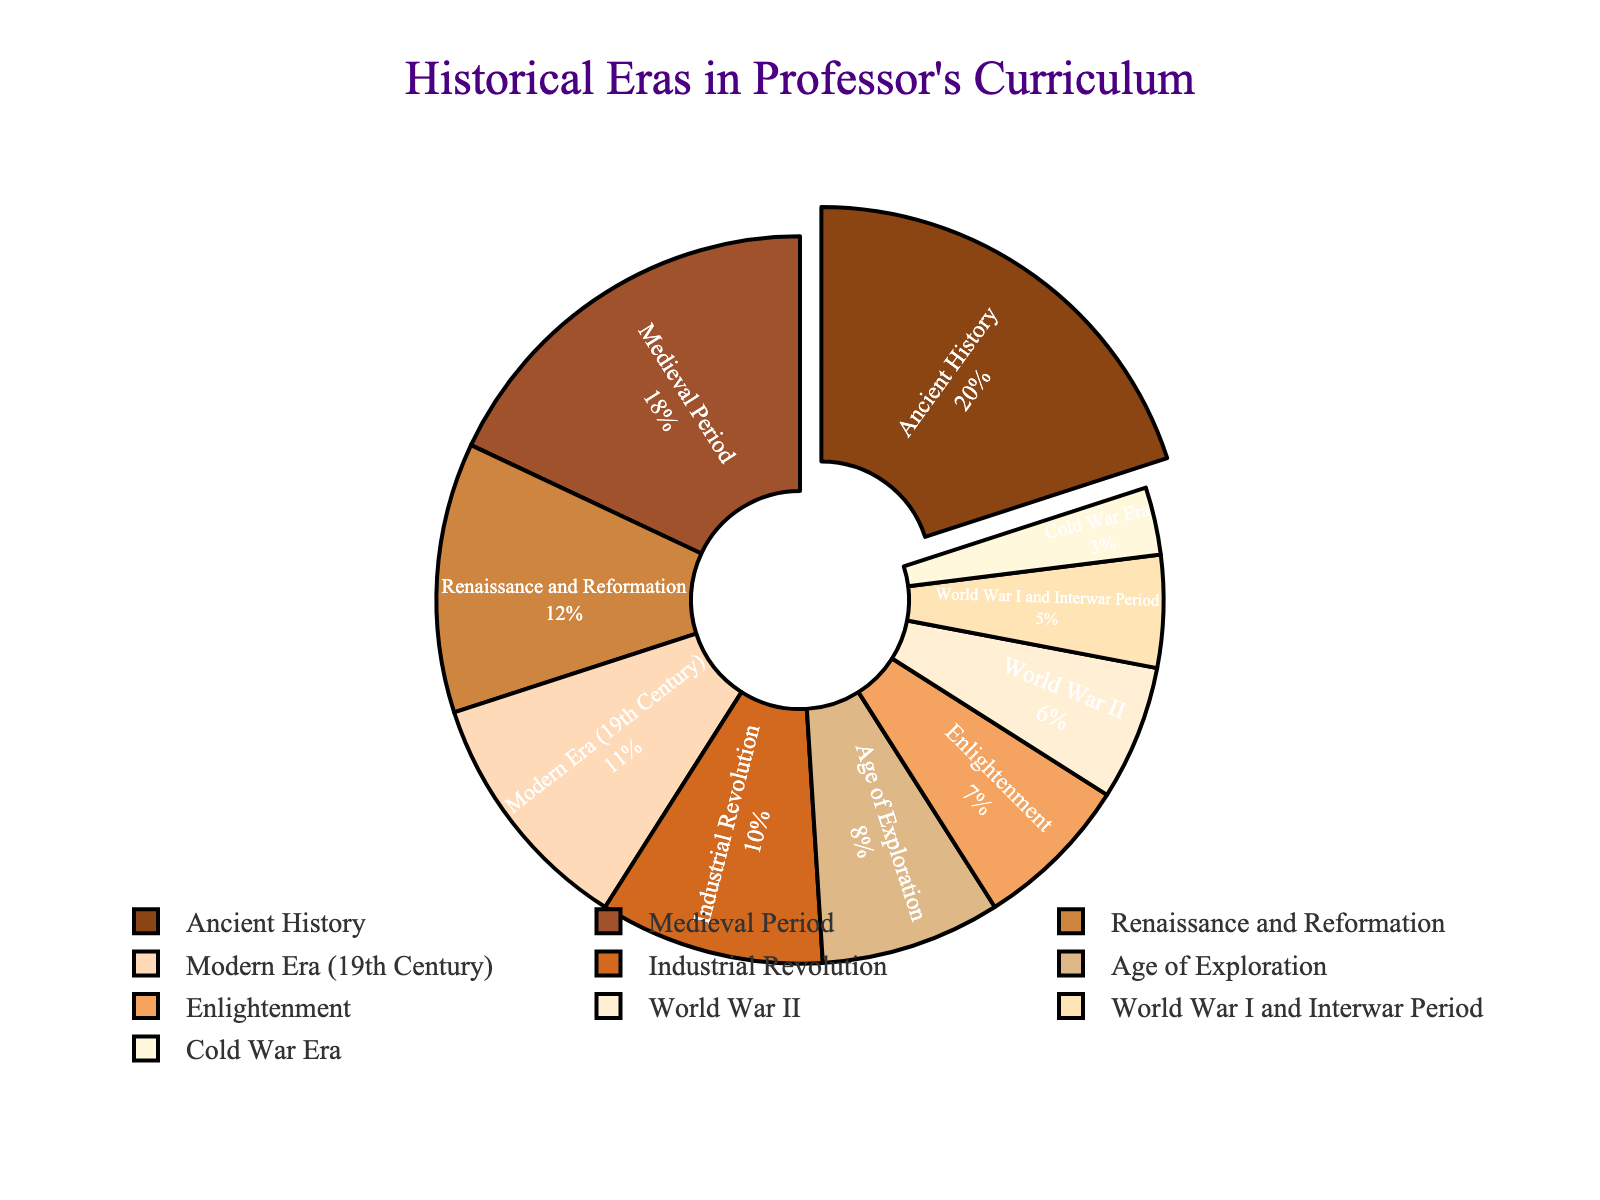what era covers the highest percentage in the curriculum? The figure highlights the era with the highest percentage by pulling that segment out of the pie chart. The segment labeled "Ancient History" is visibly separated from the rest of the chart and includes the label "20%", indicating it is the highest.
Answer: Ancient History how does the percentage of the Medieval Period compare to that of the Renaissance and Reformation? By observing the pie chart, the segment labeled "Medieval Period" shows 18%, and the "Renaissance and Reformation" shows 12%. Comparing these values, the Medieval Period covers more of the curriculum than the Renaissance and Reformation.
Answer: Medieval Period has 6% more what is the total percentage covered by the Age of Exploration and Enlightenment combined? The pie chart shows the "Age of Exploration" is 8%, and the "Enlightenment" is 7%. Adding these percentages, 8% + 7% = 15%.
Answer: 15% which era has the smallest representation in the curriculum? The pie chart includes a small segment labeled "Cold War Era" with 3%, making it the smallest represented era in the curriculum.
Answer: Cold War Era what fraction of the curriculum does the Modern Era (19th Century) cover in relation to the total percentage of World War II and World War I and Interwar Period combined? The Modern Era is 11%. World War II is 6%, and World War I and Interwar Period is 5%. Adding these together, 6% + 5% = 11%. The fraction is then 11% (Modern Era) / 11% (WWI + WWII) = 1.
Answer: 1 which era is represented with a darker shade of brown? The pie chart uses darker shades of brown for more significant percentages. Observing the darker shade, "Ancient History" is represented by a darker brown and covers 20%, the largest segment.
Answer: Ancient History how much more of the curriculum does the Ancient History cover compared to the Industrial Revolution? "Ancient History" covers 20%, and the "Industrial Revolution" covers 10%. The difference is 20% - 10% = 10%.
Answer: 10% if you combine the percentages of World War I, World War II, and the Cold War Era, what is their total contribution to the curriculum? The percentages are World War I (5%), World War II (6%), and Cold War Era (3%). Adding them gives us 5% + 6% + 3% = 14%.
Answer: 14% which era’s segment is placed closest to the Medieval Period's segment? Observing the adjacent segments, "Renaissance and Reformation" (12%) is placed next to "Medieval Period" (18%) in the pie chart.
Answer: Renaissance and Reformation 